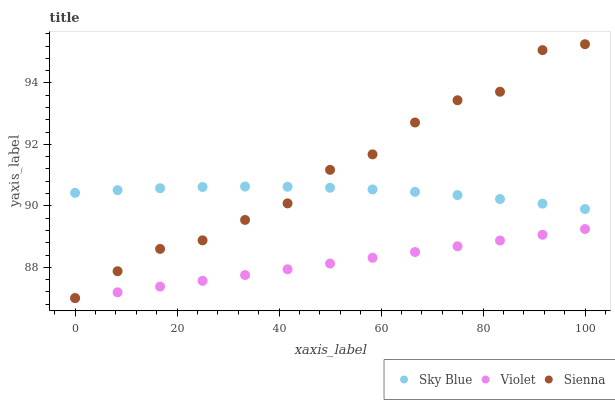Does Violet have the minimum area under the curve?
Answer yes or no. Yes. Does Sienna have the maximum area under the curve?
Answer yes or no. Yes. Does Sky Blue have the minimum area under the curve?
Answer yes or no. No. Does Sky Blue have the maximum area under the curve?
Answer yes or no. No. Is Violet the smoothest?
Answer yes or no. Yes. Is Sienna the roughest?
Answer yes or no. Yes. Is Sky Blue the smoothest?
Answer yes or no. No. Is Sky Blue the roughest?
Answer yes or no. No. Does Sienna have the lowest value?
Answer yes or no. Yes. Does Sky Blue have the lowest value?
Answer yes or no. No. Does Sienna have the highest value?
Answer yes or no. Yes. Does Sky Blue have the highest value?
Answer yes or no. No. Is Violet less than Sky Blue?
Answer yes or no. Yes. Is Sky Blue greater than Violet?
Answer yes or no. Yes. Does Sienna intersect Violet?
Answer yes or no. Yes. Is Sienna less than Violet?
Answer yes or no. No. Is Sienna greater than Violet?
Answer yes or no. No. Does Violet intersect Sky Blue?
Answer yes or no. No. 